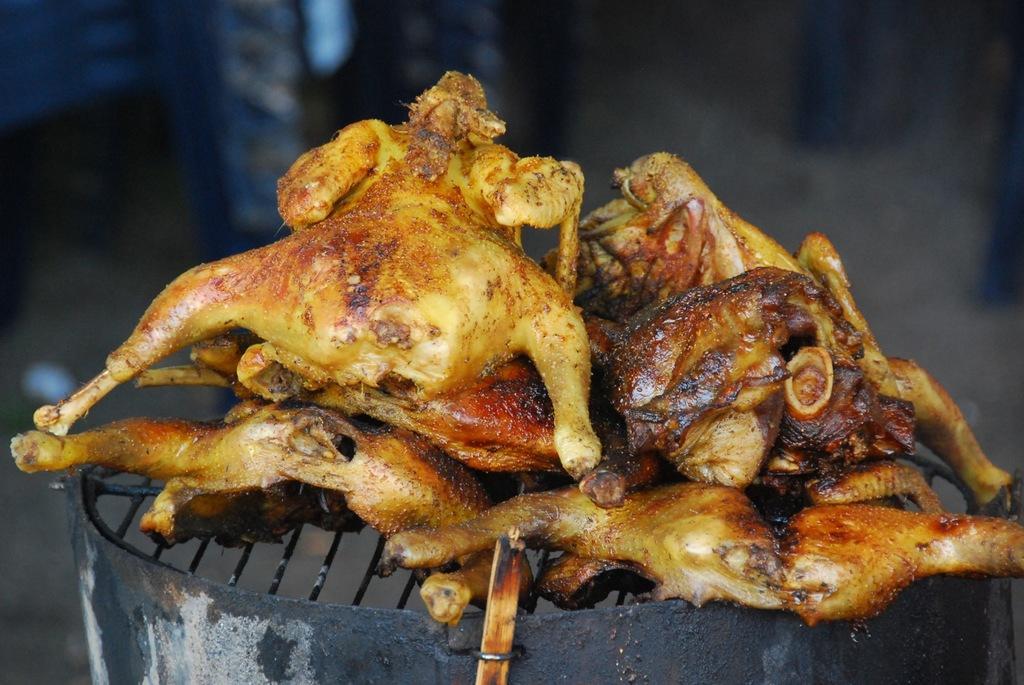In one or two sentences, can you explain what this image depicts? In this image I can see a black colour thing and on it I can see number of meat pieces. On the bottom side of this image I can see a wooden stick and I can also see this image is little bit blurry in the background. 